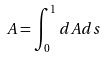Convert formula to latex. <formula><loc_0><loc_0><loc_500><loc_500>A = \int _ { 0 } ^ { 1 } d A d s</formula> 